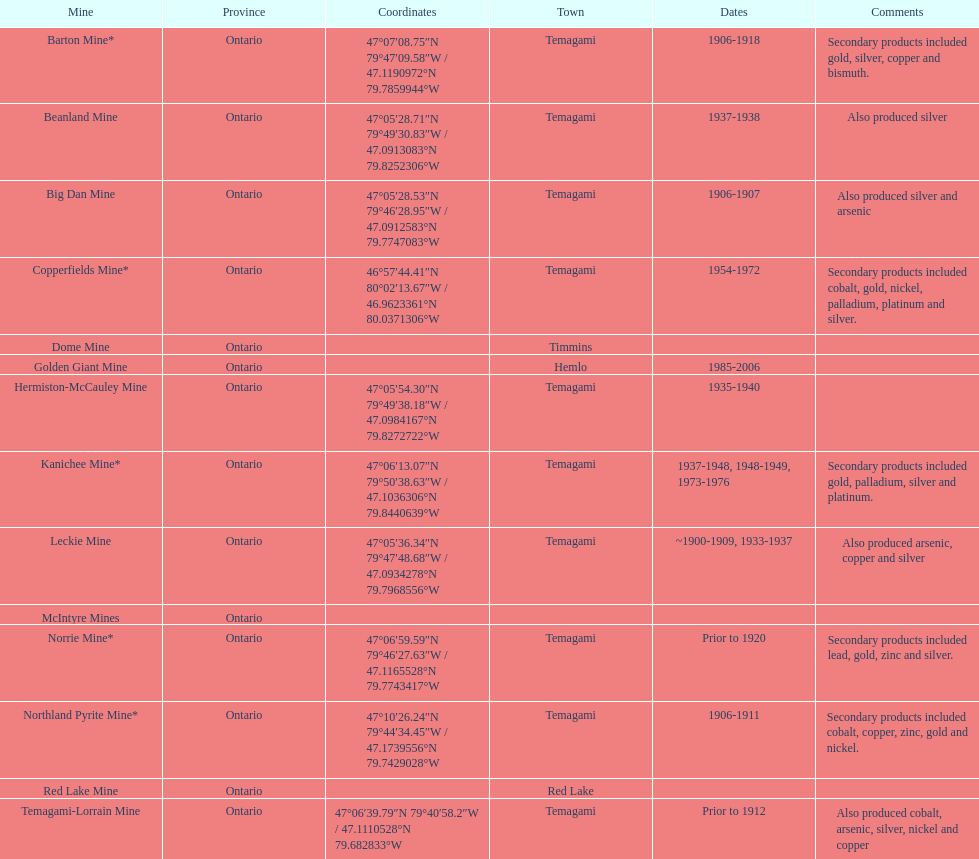Tell me the number of mines that also produced arsenic. 3. 